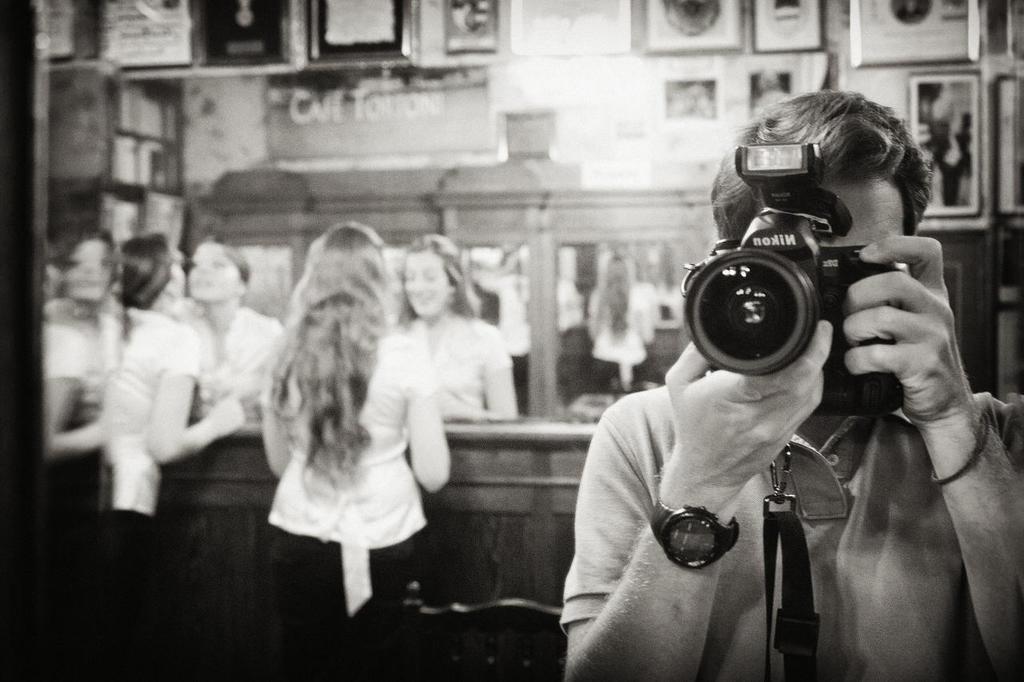Could you give a brief overview of what you see in this image? In this picture there is a person holding a camera, in both of his hands, in the right of there are two women standing peeing themselves in the mirror. 